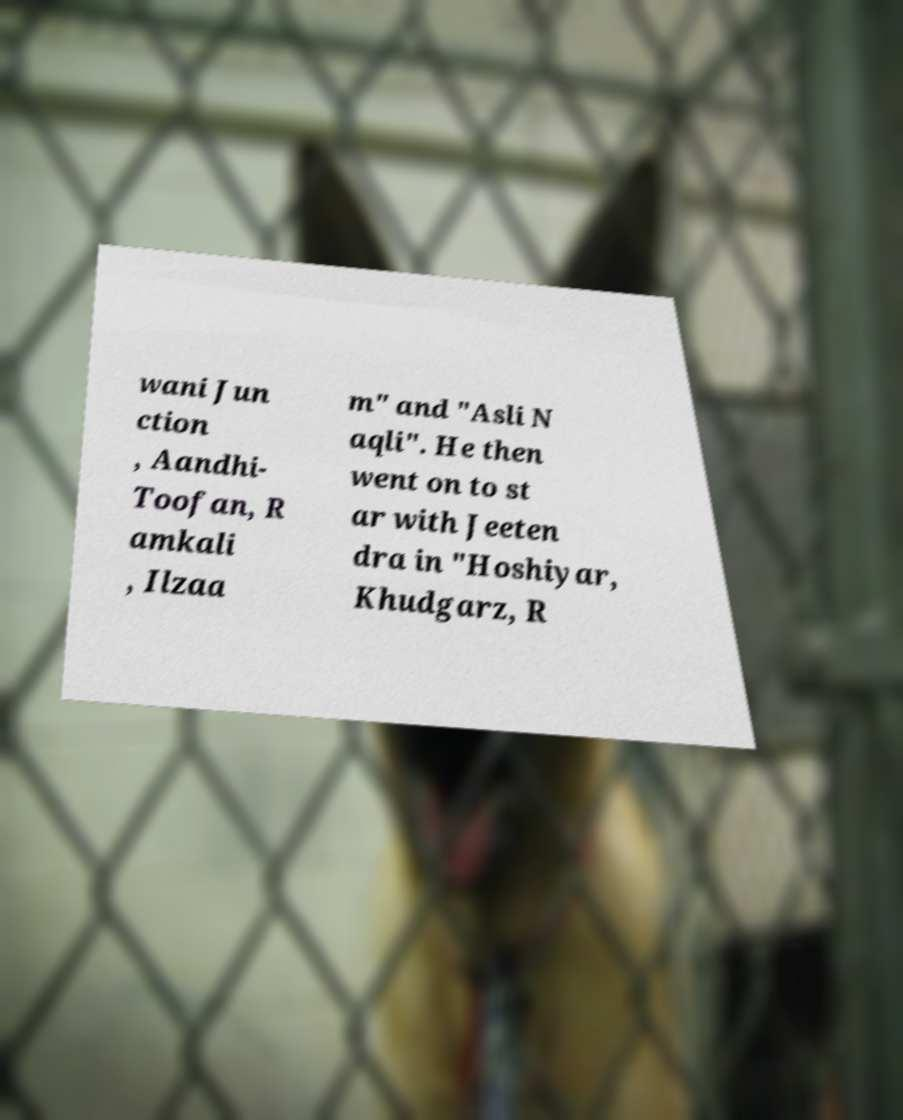Could you assist in decoding the text presented in this image and type it out clearly? wani Jun ction , Aandhi- Toofan, R amkali , Ilzaa m" and "Asli N aqli". He then went on to st ar with Jeeten dra in "Hoshiyar, Khudgarz, R 